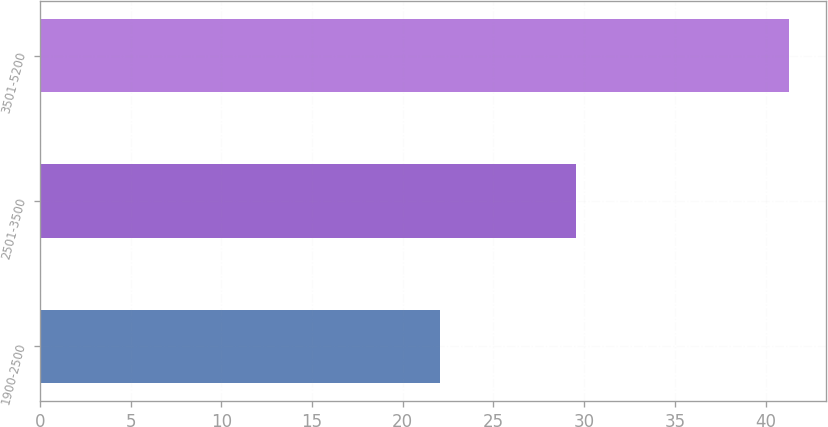Convert chart. <chart><loc_0><loc_0><loc_500><loc_500><bar_chart><fcel>1900-2500<fcel>2501-3500<fcel>3501-5200<nl><fcel>22.05<fcel>29.55<fcel>41.29<nl></chart> 